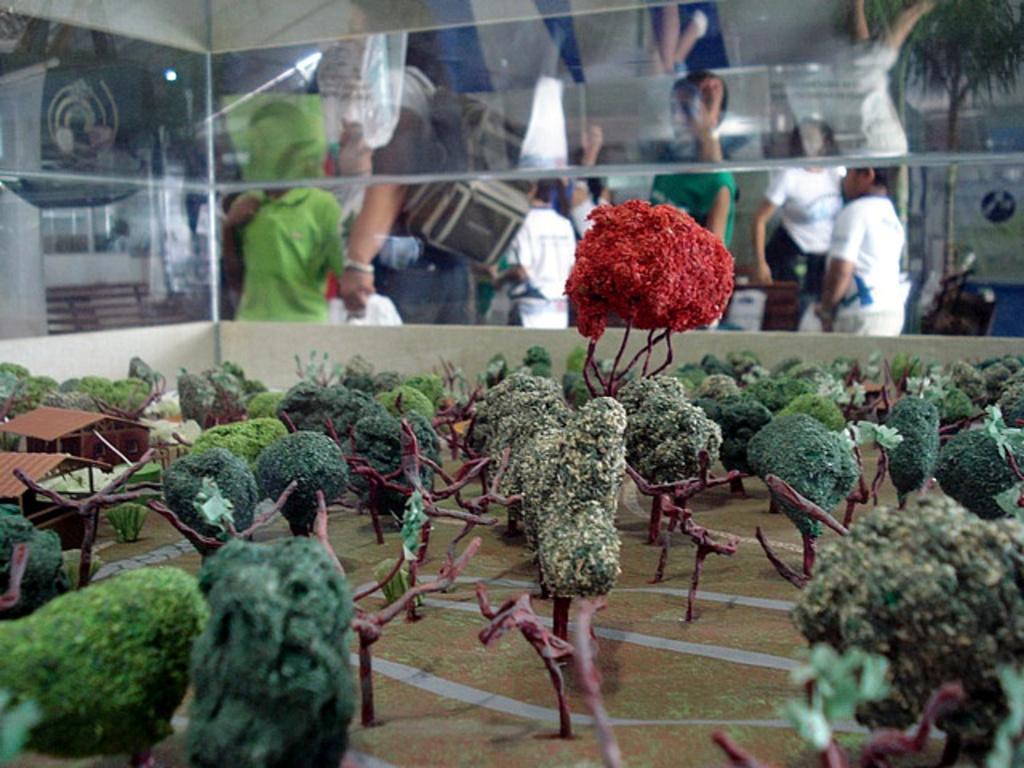Could you give a brief overview of what you see in this image? In this picture we can see a model. We can see a few trees, houses and bushes on the ground. There are some glass objects visible on top of the picture. Through these glass objects, we can see a few people and other objects in the background. 